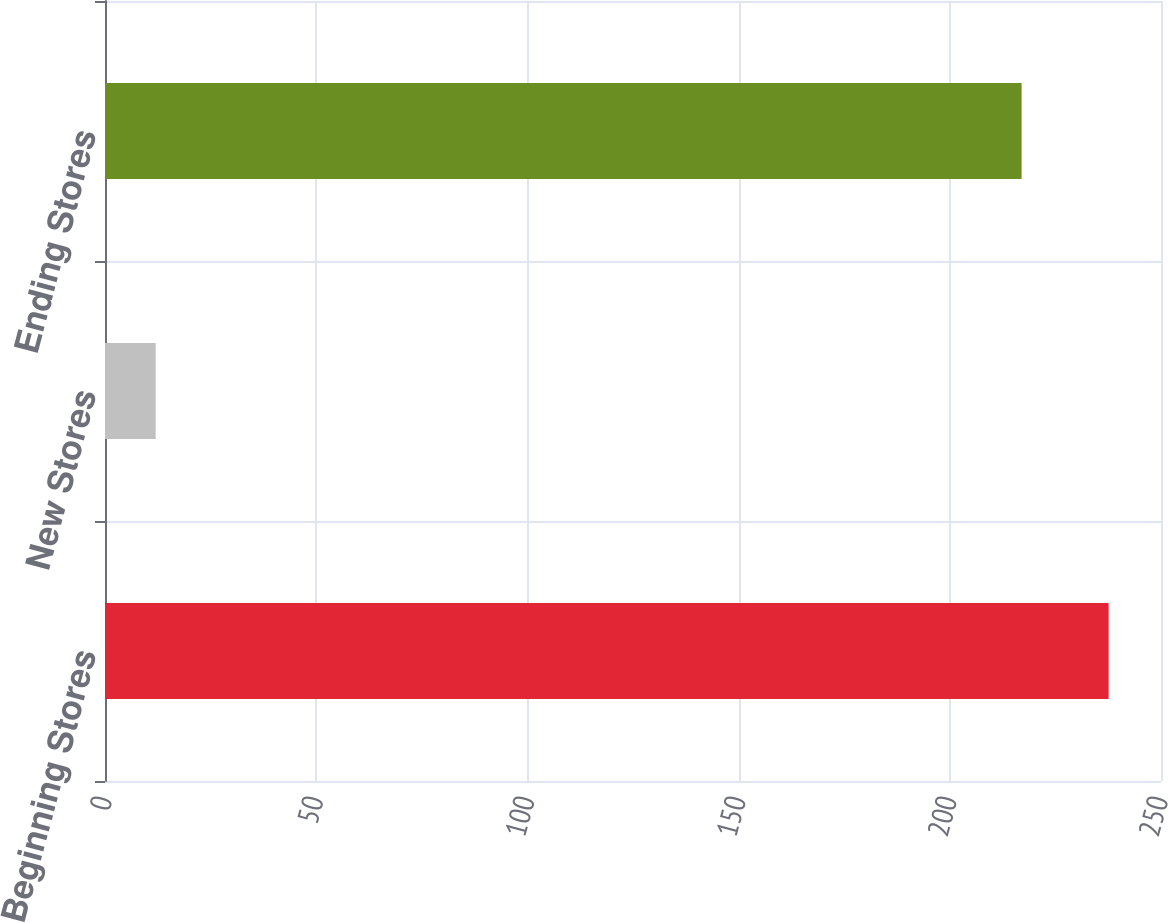<chart> <loc_0><loc_0><loc_500><loc_500><bar_chart><fcel>Beginning Stores<fcel>New Stores<fcel>Ending Stores<nl><fcel>237.6<fcel>12<fcel>217<nl></chart> 